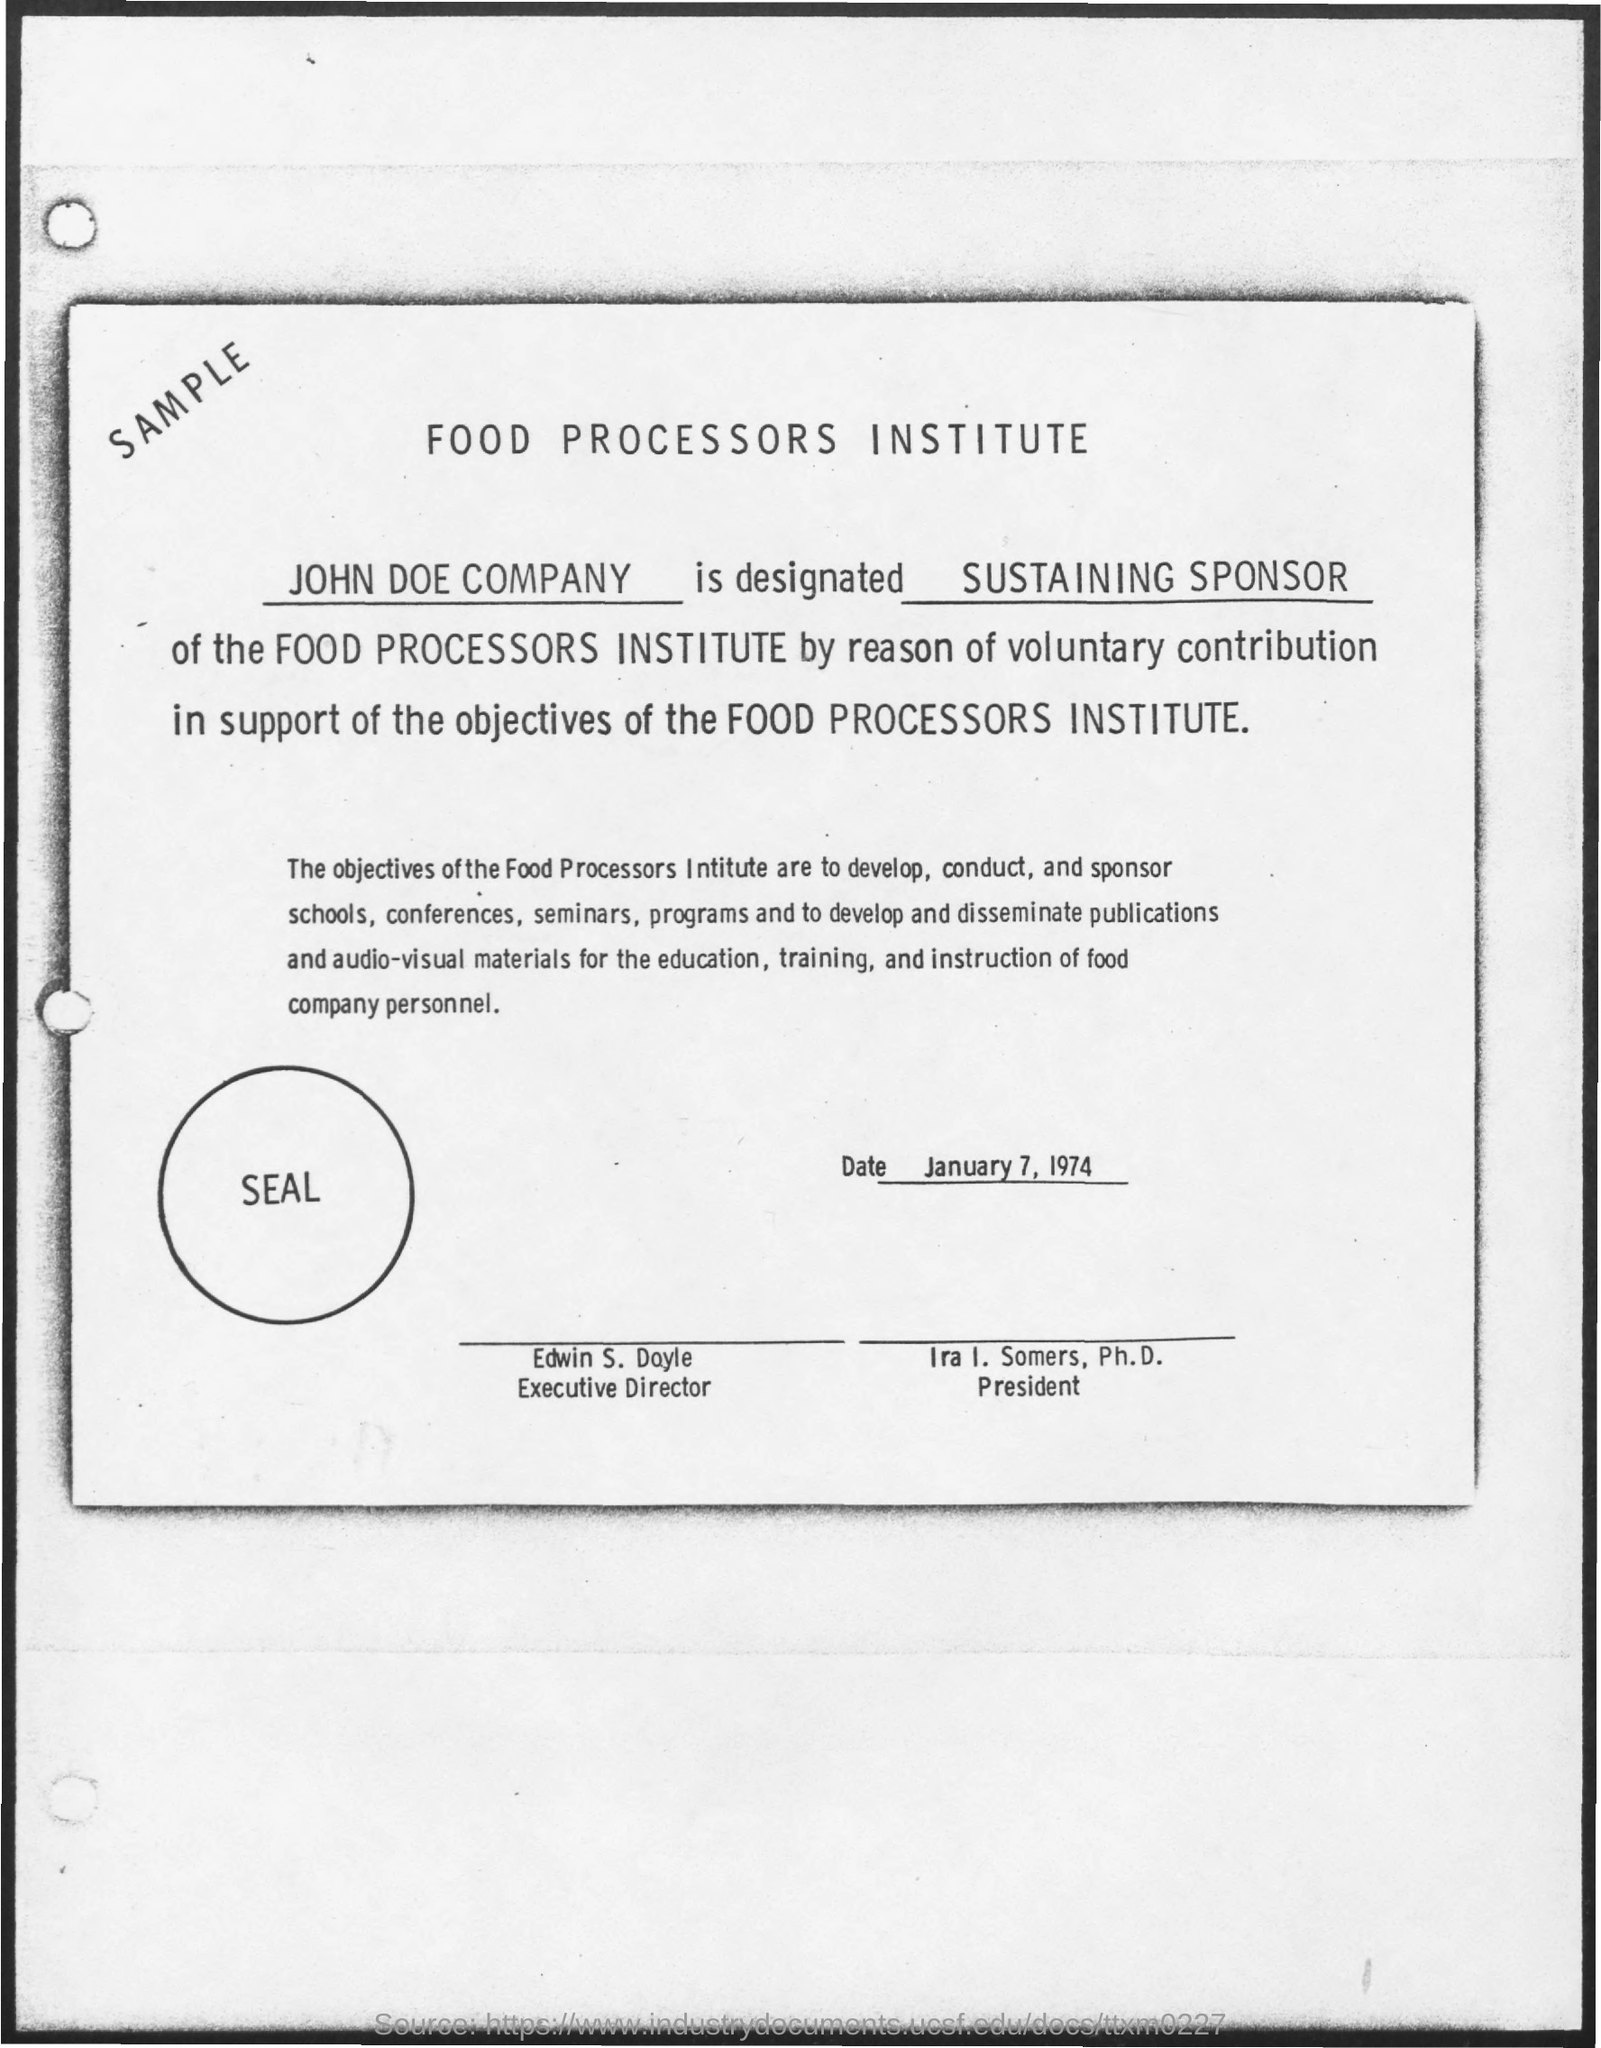Who is the Executive Director?
Give a very brief answer. Edwin s. doyle. What is the date mentioned in the document?
Provide a short and direct response. January 7, 1974. Which text is in the circle?
Make the answer very short. Seal. Which text is at the top-left?
Provide a short and direct response. Sample. What is the title of the document?
Give a very brief answer. Food Processors Institute. 